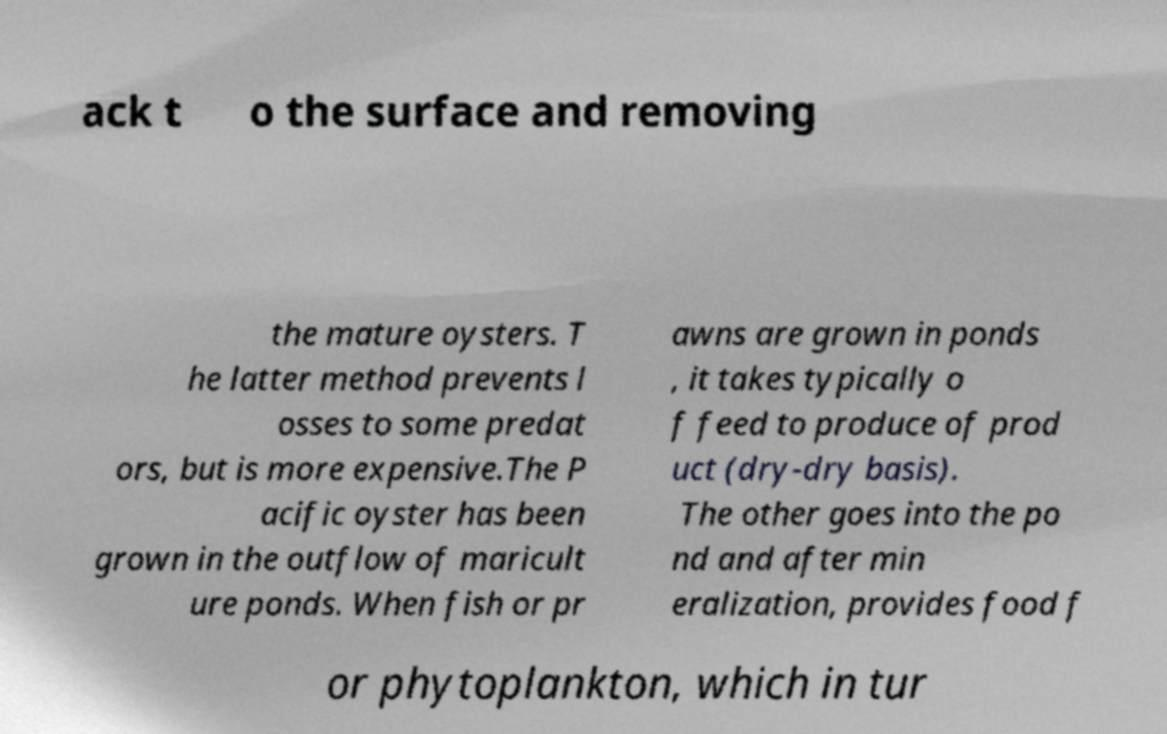Please read and relay the text visible in this image. What does it say? ack t o the surface and removing the mature oysters. T he latter method prevents l osses to some predat ors, but is more expensive.The P acific oyster has been grown in the outflow of maricult ure ponds. When fish or pr awns are grown in ponds , it takes typically o f feed to produce of prod uct (dry-dry basis). The other goes into the po nd and after min eralization, provides food f or phytoplankton, which in tur 